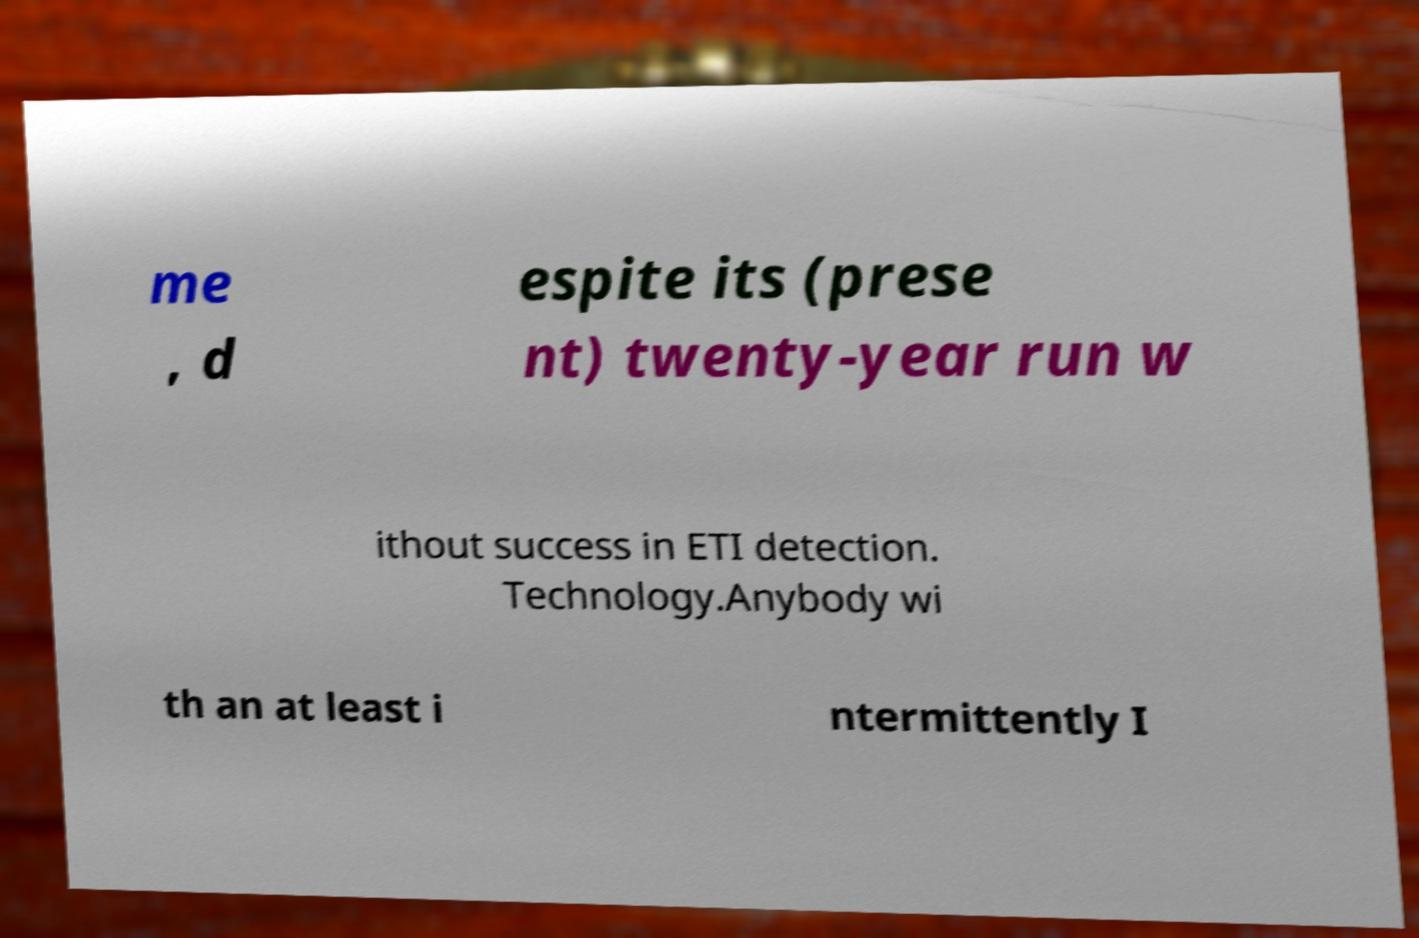There's text embedded in this image that I need extracted. Can you transcribe it verbatim? me , d espite its (prese nt) twenty-year run w ithout success in ETI detection. Technology.Anybody wi th an at least i ntermittently I 